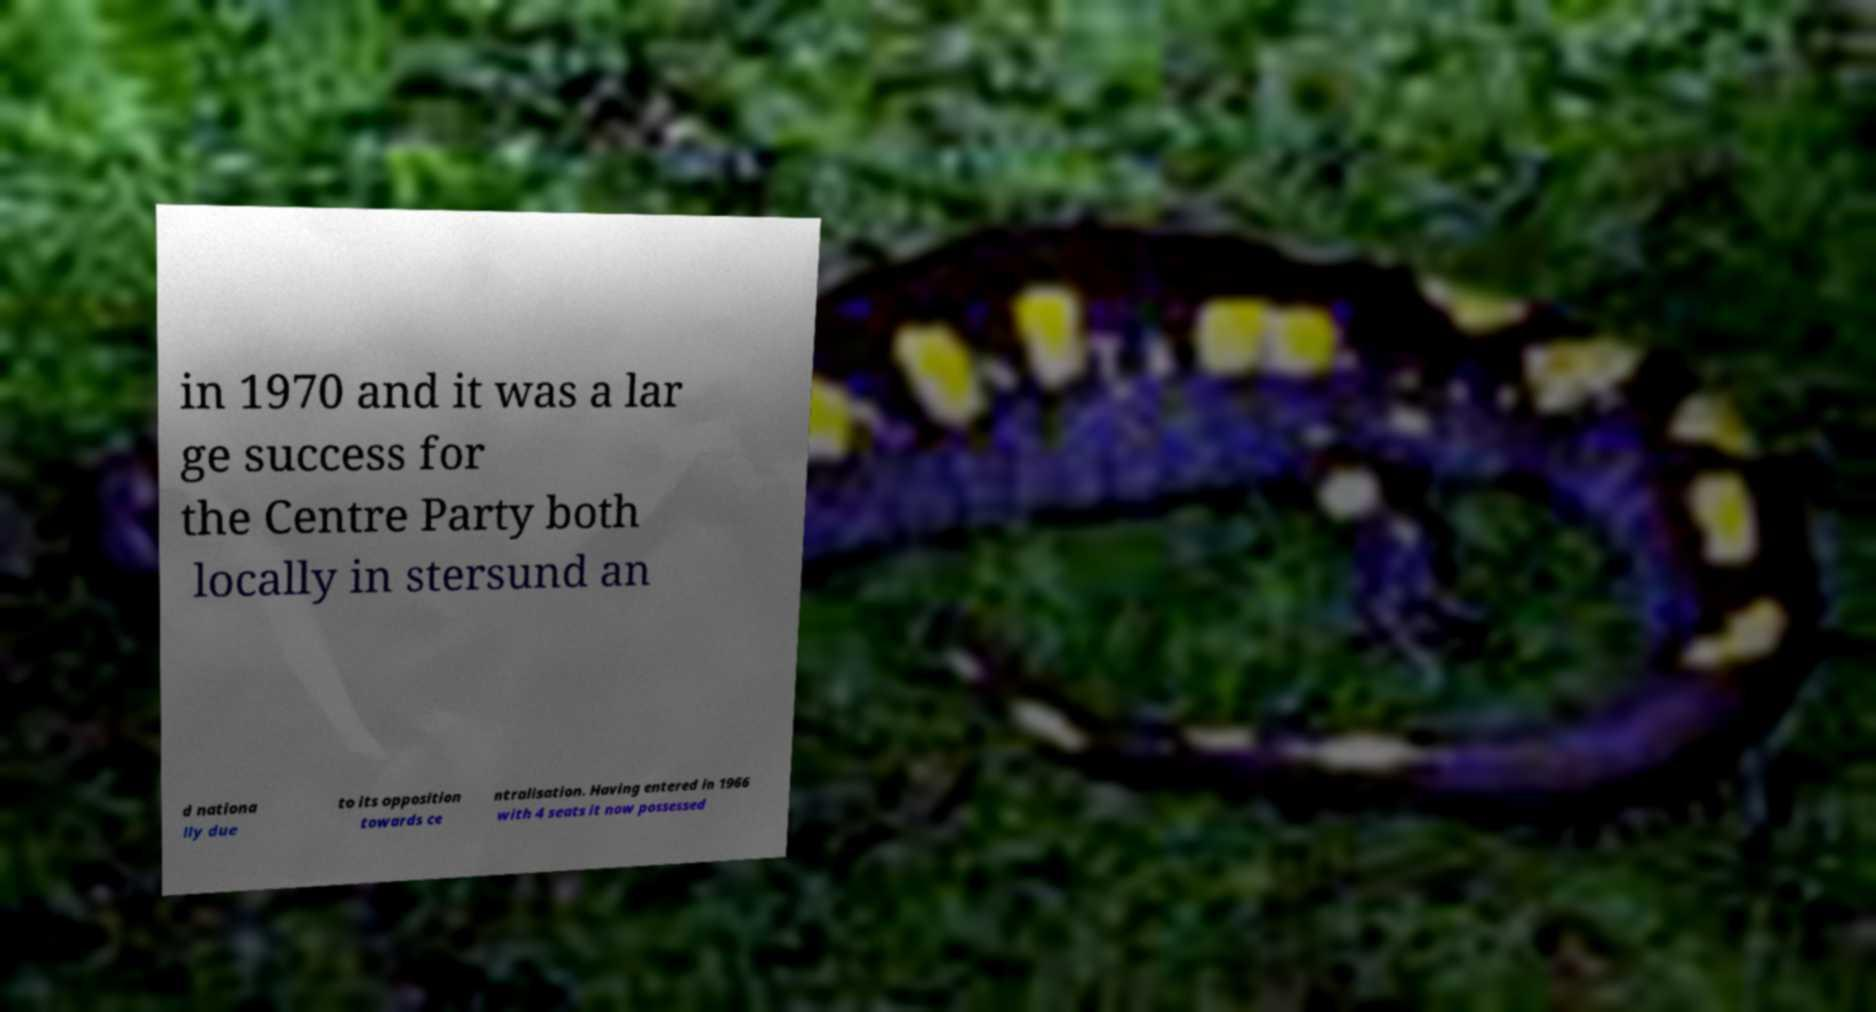I need the written content from this picture converted into text. Can you do that? in 1970 and it was a lar ge success for the Centre Party both locally in stersund an d nationa lly due to its opposition towards ce ntralisation. Having entered in 1966 with 4 seats it now possessed 